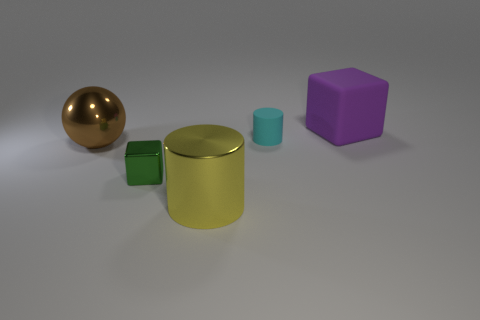There is a cube on the right side of the small thing that is behind the brown shiny ball; what number of cubes are in front of it? Looking at the arrangement of objects in the image, we notice on the right side of the cylinder, which is behind the shiny brown sphere, there is a purple cube. Directly in front of this cube, there is one green cube. So, to answer the question: there is one cube in front of the purple cube that's adjacent to the small cylinder. 